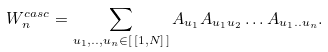<formula> <loc_0><loc_0><loc_500><loc_500>W _ { n } ^ { c a s c } = \sum _ { u _ { 1 } , . . , u _ { n } \in [ \, [ 1 , N ] \, ] } A _ { u _ { 1 } } A _ { u _ { 1 } u _ { 2 } } \dots A _ { u _ { 1 } . . u _ { n } } .</formula> 